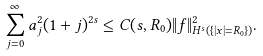<formula> <loc_0><loc_0><loc_500><loc_500>\sum _ { j = 0 } ^ { \infty } a _ { j } ^ { 2 } ( 1 + j ) ^ { 2 s } \leq C ( s , R _ { 0 } ) \| f \| _ { H ^ { s } ( \{ | x | = R _ { 0 } \} ) } ^ { 2 } .</formula> 